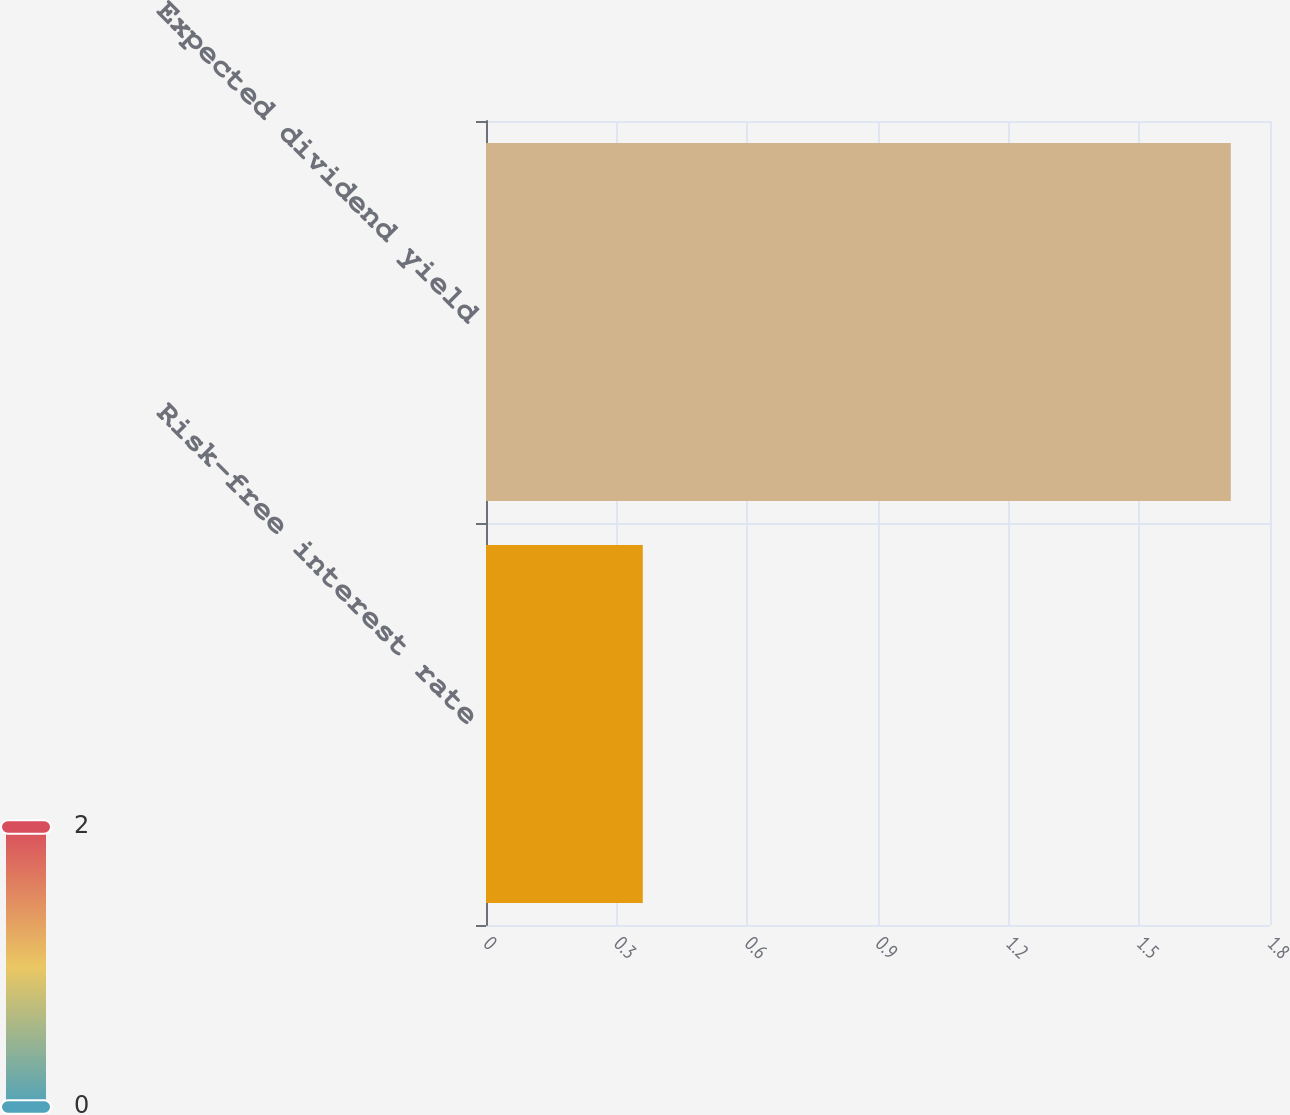Convert chart to OTSL. <chart><loc_0><loc_0><loc_500><loc_500><bar_chart><fcel>Risk-free interest rate<fcel>Expected dividend yield<nl><fcel>0.36<fcel>1.71<nl></chart> 